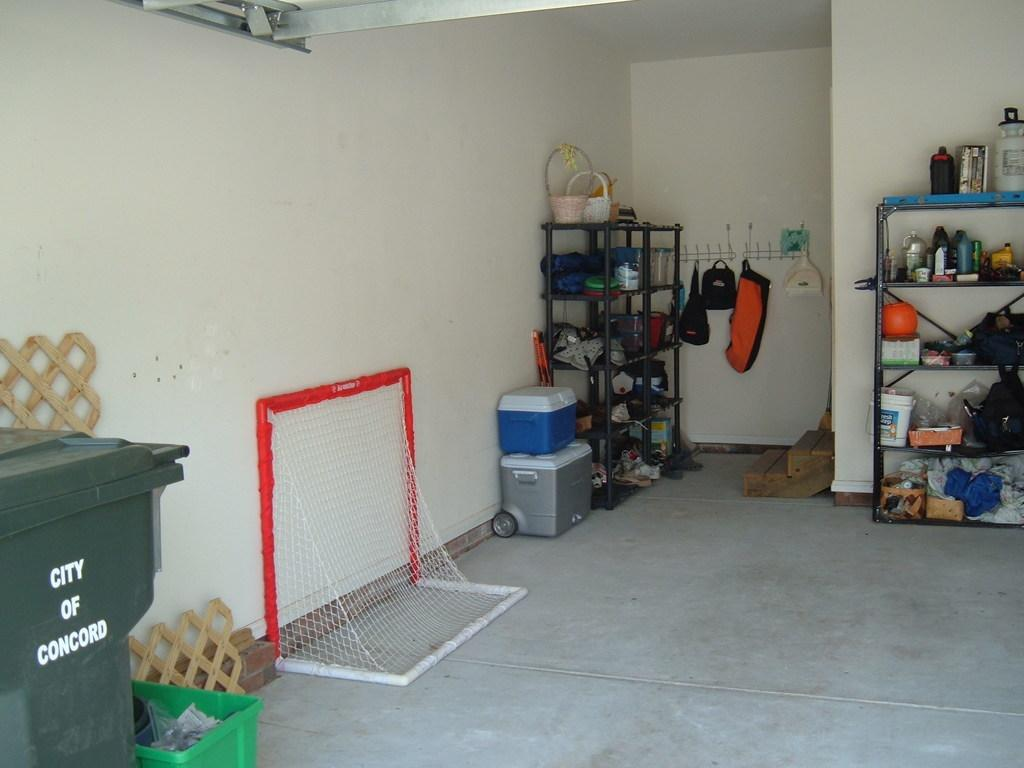<image>
Summarize the visual content of the image. a trash can in a garage that says City of Concord 